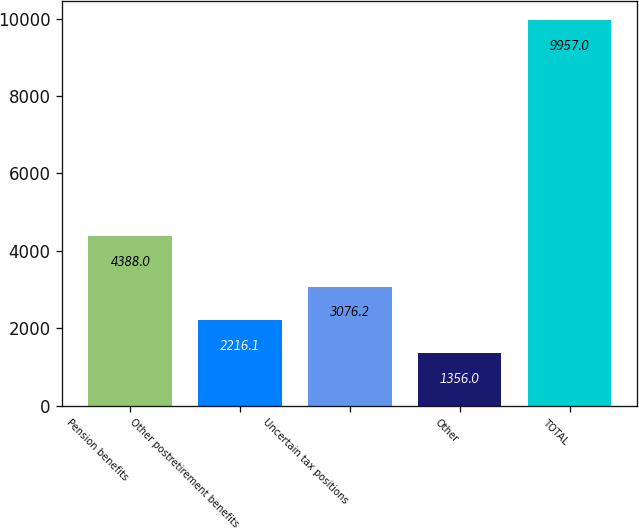Convert chart. <chart><loc_0><loc_0><loc_500><loc_500><bar_chart><fcel>Pension benefits<fcel>Other postretirement benefits<fcel>Uncertain tax positions<fcel>Other<fcel>TOTAL<nl><fcel>4388<fcel>2216.1<fcel>3076.2<fcel>1356<fcel>9957<nl></chart> 